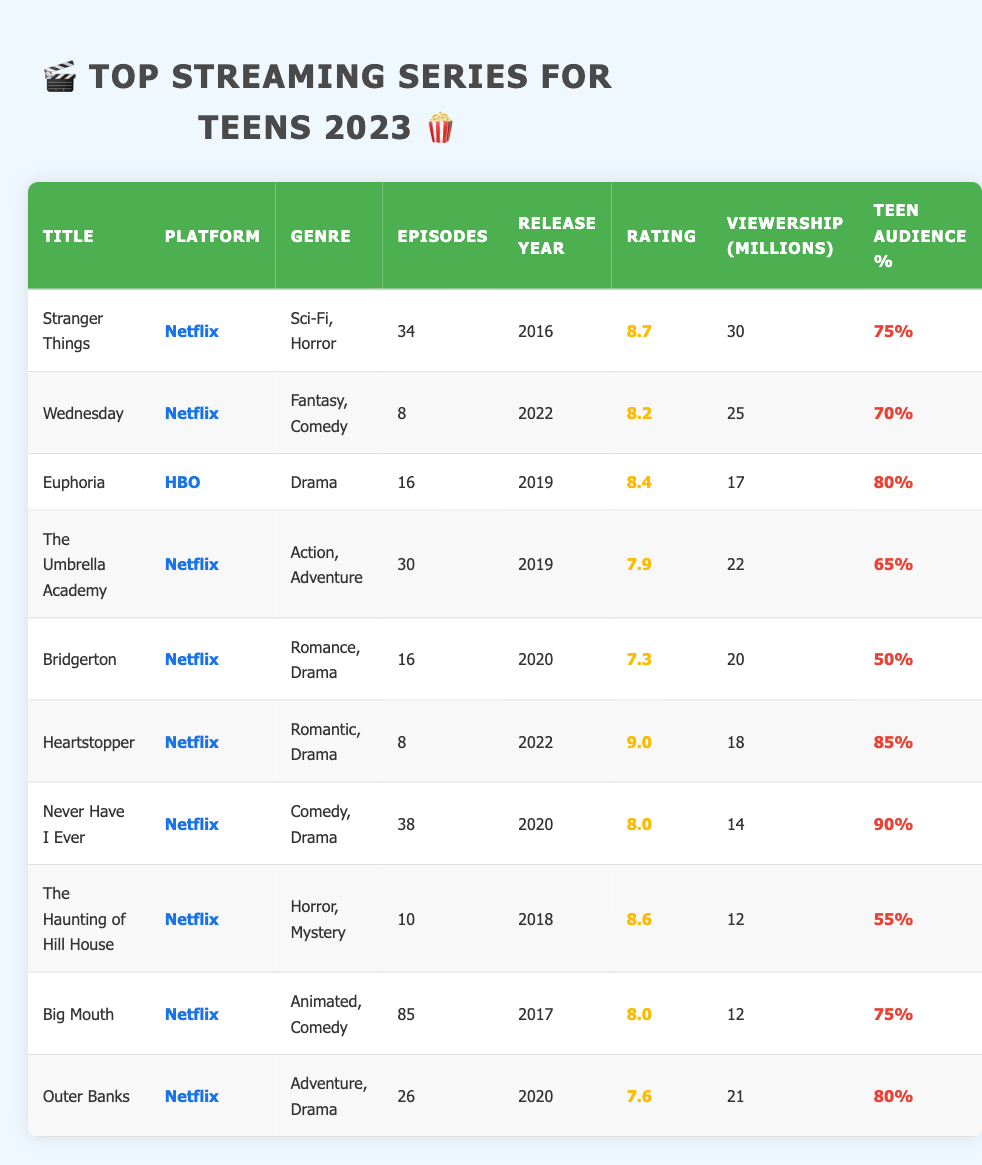What is the title of the series with the highest rating? The series with the highest rating is "Heartstopper," which has a rating of 9.0.
Answer: Heartstopper Which platform has the most series listed? All listed series are on Netflix, confirming that Netflix is the only platform in the table.
Answer: Netflix How many episodes does "Never Have I Ever" have? The series "Never Have I Ever" has 38 episodes, as indicated in the table.
Answer: 38 What is the average rating of all series? The sum of the ratings is (8.7 + 8.2 + 8.4 + 7.9 + 7.3 + 9.0 + 8.0 + 8.6 + 8.0 + 7.6) = 80.7. There are 10 series, so the average rating is 80.7 / 10 = 8.07.
Answer: 8.07 Which series has the lowest teen audience percentage and what is it? "Bridgerton" has the lowest teen audience percentage at 50%.
Answer: Bridgerton, 50% How many series have a teen audience percentage of 80% or higher? The series with 80% or higher are "Euphoria," "Heartstopper," "Never Have I Ever," and "Outer Banks." That's four series in total.
Answer: 4 What is the viewership of "Stranger Things"? The viewership of "Stranger Things" is 30 million, as shown in the table.
Answer: 30 million Is "Wednesday" rated higher than "Bridgerton"? Yes, "Wednesday" has a rating of 8.2, while "Bridgerton" has a rating of 7.3, indicating that Wednesday is rated higher.
Answer: Yes What is the total viewership of all the Netflix series listed? The viewership of all Netflix series is summed up as (30 + 25 + 22 + 20 + 18 + 14 + 12 + 12 + 21) =  164 million.
Answer: 164 million Which genre has the most series represented in the table? The "Drama" genre has the most series with three entries: "Euphoria," "Bridgerton," and "Outer Banks."
Answer: Drama 